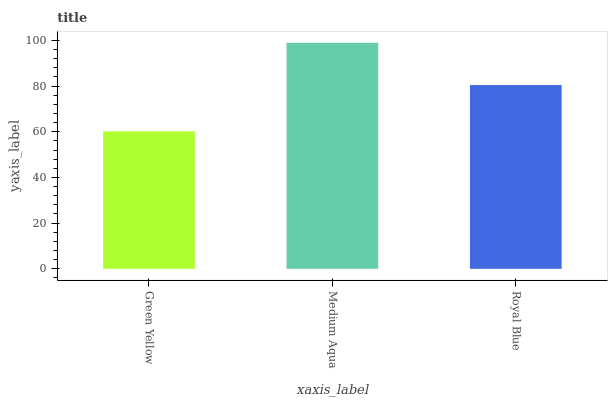Is Green Yellow the minimum?
Answer yes or no. Yes. Is Medium Aqua the maximum?
Answer yes or no. Yes. Is Royal Blue the minimum?
Answer yes or no. No. Is Royal Blue the maximum?
Answer yes or no. No. Is Medium Aqua greater than Royal Blue?
Answer yes or no. Yes. Is Royal Blue less than Medium Aqua?
Answer yes or no. Yes. Is Royal Blue greater than Medium Aqua?
Answer yes or no. No. Is Medium Aqua less than Royal Blue?
Answer yes or no. No. Is Royal Blue the high median?
Answer yes or no. Yes. Is Royal Blue the low median?
Answer yes or no. Yes. Is Green Yellow the high median?
Answer yes or no. No. Is Medium Aqua the low median?
Answer yes or no. No. 